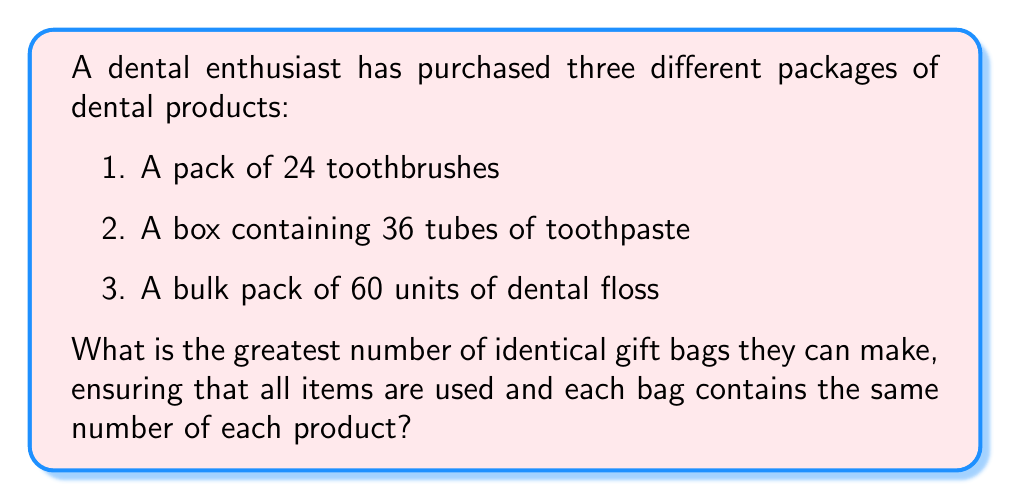Help me with this question. To solve this problem, we need to find the Greatest Common Divisor (GCD) of the three numbers: 24, 36, and 60.

Let's use the Euclidean algorithm to find the GCD:

1) First, let's find the GCD of 24 and 36:
   $$36 = 1 \times 24 + 12$$
   $$24 = 2 \times 12 + 0$$
   Therefore, $GCD(24, 36) = 12$

2) Now, let's find the GCD of 12 and 60:
   $$60 = 5 \times 12 + 0$$
   Therefore, $GCD(12, 60) = 12$

3) Since $GCD(24, 36) = 12$ and $GCD(12, 60) = 12$, we can conclude that:
   $$GCD(24, 36, 60) = 12$$

This means that the dental enthusiast can make 12 identical gift bags.

To verify:
- Each bag will contain $24 \div 12 = 2$ toothbrushes
- Each bag will contain $36 \div 12 = 3$ tubes of toothpaste
- Each bag will contain $60 \div 12 = 5$ units of dental floss

All products are used, and each bag contains the same number of each item.
Answer: 12 